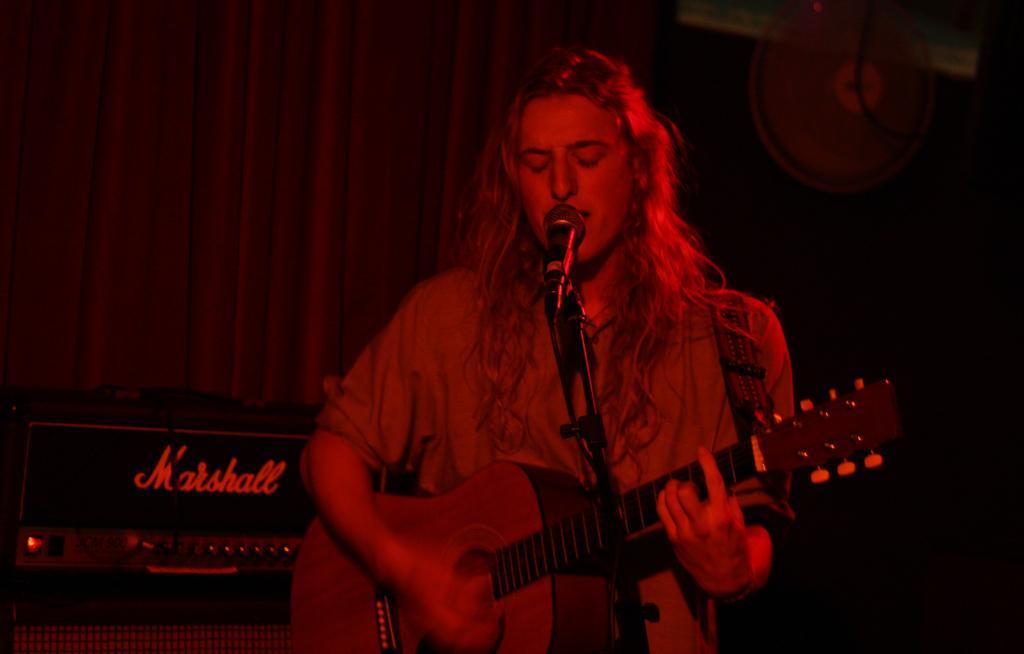Could you give a brief overview of what you see in this image? In this image, there is a person standing and singing a song in front of mike and playing a guitar. In the left bottom of the image, there is a sound box kept on the table. In the background there is a curtain which is red in color. This image is taken in a hall. 